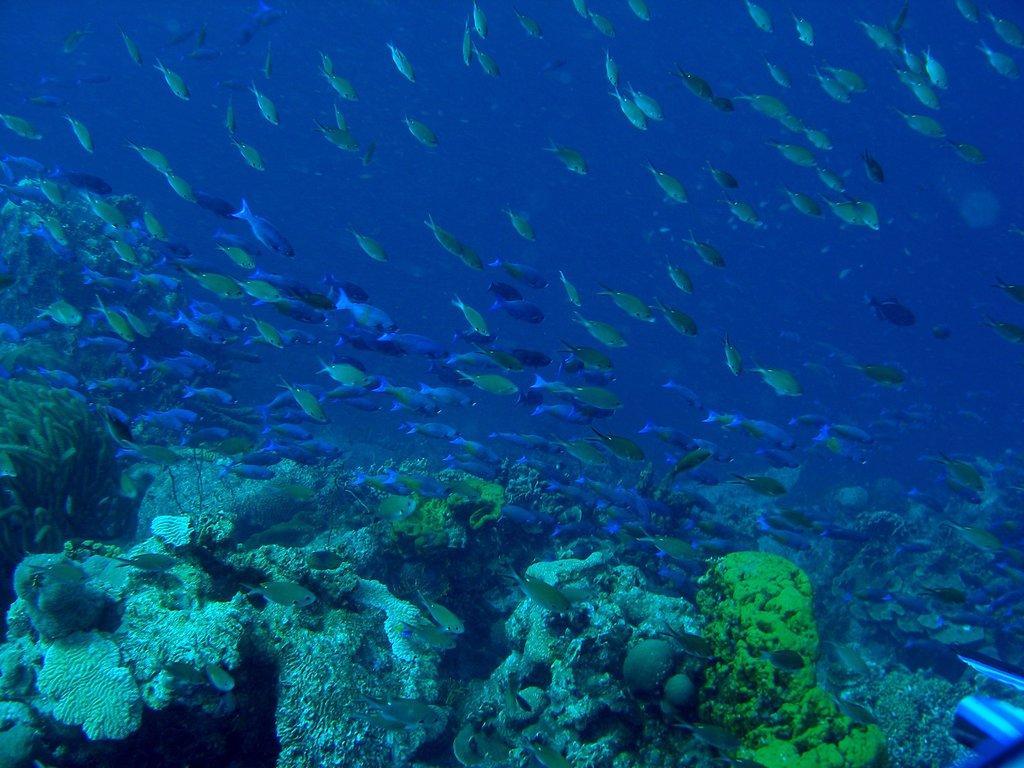Can you describe this image briefly? In this image, we can see some fishes, plants and rocks. We can also see an object at the bottom right corner. 